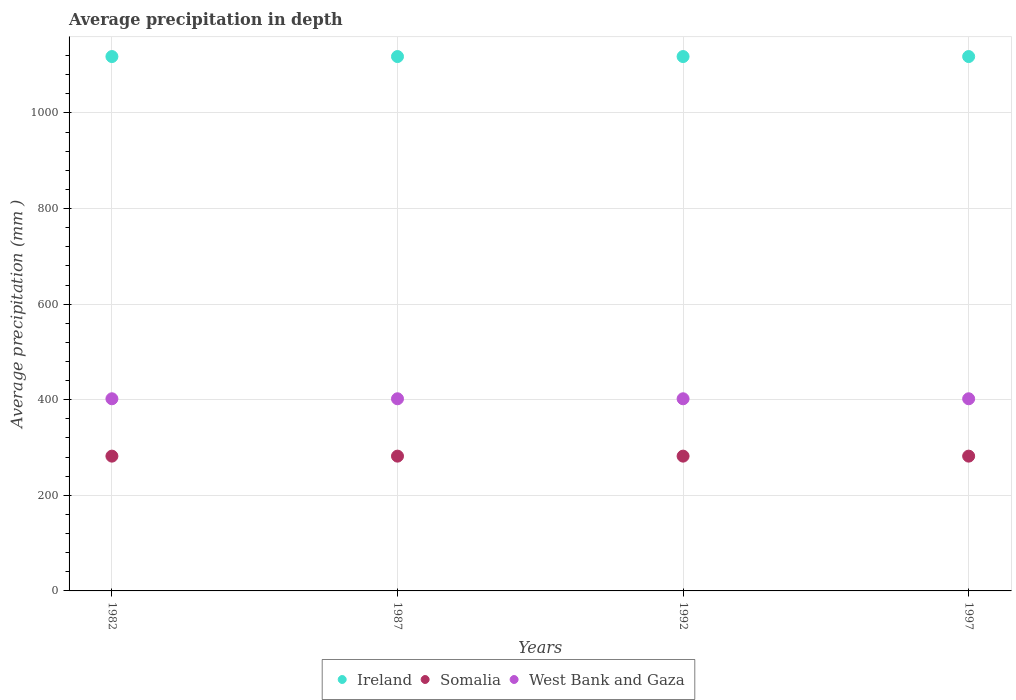What is the average precipitation in Somalia in 1992?
Your answer should be compact. 282. Across all years, what is the maximum average precipitation in West Bank and Gaza?
Your answer should be very brief. 402. Across all years, what is the minimum average precipitation in West Bank and Gaza?
Keep it short and to the point. 402. In which year was the average precipitation in Somalia minimum?
Offer a very short reply. 1982. What is the total average precipitation in Somalia in the graph?
Keep it short and to the point. 1128. What is the difference between the average precipitation in Ireland in 1987 and that in 1992?
Your response must be concise. 0. What is the difference between the average precipitation in Somalia in 1982 and the average precipitation in Ireland in 1987?
Make the answer very short. -836. What is the average average precipitation in West Bank and Gaza per year?
Provide a short and direct response. 402. In the year 1987, what is the difference between the average precipitation in West Bank and Gaza and average precipitation in Somalia?
Give a very brief answer. 120. What is the ratio of the average precipitation in Somalia in 1987 to that in 1997?
Make the answer very short. 1. Is the difference between the average precipitation in West Bank and Gaza in 1987 and 1997 greater than the difference between the average precipitation in Somalia in 1987 and 1997?
Keep it short and to the point. No. What is the difference between the highest and the second highest average precipitation in Somalia?
Offer a very short reply. 0. What is the difference between the highest and the lowest average precipitation in Somalia?
Offer a very short reply. 0. Is the average precipitation in Ireland strictly greater than the average precipitation in Somalia over the years?
Make the answer very short. Yes. Is the average precipitation in West Bank and Gaza strictly less than the average precipitation in Somalia over the years?
Provide a short and direct response. No. How many years are there in the graph?
Provide a short and direct response. 4. What is the difference between two consecutive major ticks on the Y-axis?
Your response must be concise. 200. Are the values on the major ticks of Y-axis written in scientific E-notation?
Ensure brevity in your answer.  No. Does the graph contain any zero values?
Your answer should be compact. No. Does the graph contain grids?
Ensure brevity in your answer.  Yes. What is the title of the graph?
Provide a succinct answer. Average precipitation in depth. Does "Lao PDR" appear as one of the legend labels in the graph?
Ensure brevity in your answer.  No. What is the label or title of the X-axis?
Offer a very short reply. Years. What is the label or title of the Y-axis?
Make the answer very short. Average precipitation (mm ). What is the Average precipitation (mm ) in Ireland in 1982?
Your answer should be compact. 1118. What is the Average precipitation (mm ) in Somalia in 1982?
Provide a short and direct response. 282. What is the Average precipitation (mm ) in West Bank and Gaza in 1982?
Ensure brevity in your answer.  402. What is the Average precipitation (mm ) of Ireland in 1987?
Keep it short and to the point. 1118. What is the Average precipitation (mm ) in Somalia in 1987?
Make the answer very short. 282. What is the Average precipitation (mm ) of West Bank and Gaza in 1987?
Your answer should be very brief. 402. What is the Average precipitation (mm ) of Ireland in 1992?
Provide a short and direct response. 1118. What is the Average precipitation (mm ) of Somalia in 1992?
Keep it short and to the point. 282. What is the Average precipitation (mm ) of West Bank and Gaza in 1992?
Your answer should be very brief. 402. What is the Average precipitation (mm ) of Ireland in 1997?
Offer a very short reply. 1118. What is the Average precipitation (mm ) in Somalia in 1997?
Offer a terse response. 282. What is the Average precipitation (mm ) of West Bank and Gaza in 1997?
Your response must be concise. 402. Across all years, what is the maximum Average precipitation (mm ) of Ireland?
Your response must be concise. 1118. Across all years, what is the maximum Average precipitation (mm ) of Somalia?
Offer a very short reply. 282. Across all years, what is the maximum Average precipitation (mm ) in West Bank and Gaza?
Keep it short and to the point. 402. Across all years, what is the minimum Average precipitation (mm ) in Ireland?
Give a very brief answer. 1118. Across all years, what is the minimum Average precipitation (mm ) of Somalia?
Provide a succinct answer. 282. Across all years, what is the minimum Average precipitation (mm ) in West Bank and Gaza?
Give a very brief answer. 402. What is the total Average precipitation (mm ) in Ireland in the graph?
Your response must be concise. 4472. What is the total Average precipitation (mm ) in Somalia in the graph?
Offer a very short reply. 1128. What is the total Average precipitation (mm ) of West Bank and Gaza in the graph?
Your answer should be very brief. 1608. What is the difference between the Average precipitation (mm ) in Ireland in 1982 and that in 1987?
Make the answer very short. 0. What is the difference between the Average precipitation (mm ) in West Bank and Gaza in 1982 and that in 1987?
Offer a terse response. 0. What is the difference between the Average precipitation (mm ) in Ireland in 1982 and that in 1992?
Provide a short and direct response. 0. What is the difference between the Average precipitation (mm ) in Somalia in 1982 and that in 1997?
Provide a succinct answer. 0. What is the difference between the Average precipitation (mm ) of West Bank and Gaza in 1982 and that in 1997?
Your answer should be compact. 0. What is the difference between the Average precipitation (mm ) in Ireland in 1987 and that in 1992?
Your answer should be very brief. 0. What is the difference between the Average precipitation (mm ) of Somalia in 1987 and that in 1992?
Your answer should be very brief. 0. What is the difference between the Average precipitation (mm ) in West Bank and Gaza in 1987 and that in 1992?
Your response must be concise. 0. What is the difference between the Average precipitation (mm ) of West Bank and Gaza in 1987 and that in 1997?
Your answer should be compact. 0. What is the difference between the Average precipitation (mm ) in Somalia in 1992 and that in 1997?
Your answer should be very brief. 0. What is the difference between the Average precipitation (mm ) of West Bank and Gaza in 1992 and that in 1997?
Keep it short and to the point. 0. What is the difference between the Average precipitation (mm ) of Ireland in 1982 and the Average precipitation (mm ) of Somalia in 1987?
Provide a succinct answer. 836. What is the difference between the Average precipitation (mm ) in Ireland in 1982 and the Average precipitation (mm ) in West Bank and Gaza in 1987?
Ensure brevity in your answer.  716. What is the difference between the Average precipitation (mm ) in Somalia in 1982 and the Average precipitation (mm ) in West Bank and Gaza in 1987?
Your response must be concise. -120. What is the difference between the Average precipitation (mm ) of Ireland in 1982 and the Average precipitation (mm ) of Somalia in 1992?
Give a very brief answer. 836. What is the difference between the Average precipitation (mm ) of Ireland in 1982 and the Average precipitation (mm ) of West Bank and Gaza in 1992?
Keep it short and to the point. 716. What is the difference between the Average precipitation (mm ) of Somalia in 1982 and the Average precipitation (mm ) of West Bank and Gaza in 1992?
Give a very brief answer. -120. What is the difference between the Average precipitation (mm ) of Ireland in 1982 and the Average precipitation (mm ) of Somalia in 1997?
Provide a short and direct response. 836. What is the difference between the Average precipitation (mm ) in Ireland in 1982 and the Average precipitation (mm ) in West Bank and Gaza in 1997?
Ensure brevity in your answer.  716. What is the difference between the Average precipitation (mm ) in Somalia in 1982 and the Average precipitation (mm ) in West Bank and Gaza in 1997?
Make the answer very short. -120. What is the difference between the Average precipitation (mm ) in Ireland in 1987 and the Average precipitation (mm ) in Somalia in 1992?
Your response must be concise. 836. What is the difference between the Average precipitation (mm ) of Ireland in 1987 and the Average precipitation (mm ) of West Bank and Gaza in 1992?
Ensure brevity in your answer.  716. What is the difference between the Average precipitation (mm ) of Somalia in 1987 and the Average precipitation (mm ) of West Bank and Gaza in 1992?
Offer a very short reply. -120. What is the difference between the Average precipitation (mm ) of Ireland in 1987 and the Average precipitation (mm ) of Somalia in 1997?
Provide a succinct answer. 836. What is the difference between the Average precipitation (mm ) in Ireland in 1987 and the Average precipitation (mm ) in West Bank and Gaza in 1997?
Ensure brevity in your answer.  716. What is the difference between the Average precipitation (mm ) of Somalia in 1987 and the Average precipitation (mm ) of West Bank and Gaza in 1997?
Your answer should be compact. -120. What is the difference between the Average precipitation (mm ) of Ireland in 1992 and the Average precipitation (mm ) of Somalia in 1997?
Make the answer very short. 836. What is the difference between the Average precipitation (mm ) in Ireland in 1992 and the Average precipitation (mm ) in West Bank and Gaza in 1997?
Provide a short and direct response. 716. What is the difference between the Average precipitation (mm ) of Somalia in 1992 and the Average precipitation (mm ) of West Bank and Gaza in 1997?
Give a very brief answer. -120. What is the average Average precipitation (mm ) in Ireland per year?
Give a very brief answer. 1118. What is the average Average precipitation (mm ) of Somalia per year?
Make the answer very short. 282. What is the average Average precipitation (mm ) in West Bank and Gaza per year?
Provide a short and direct response. 402. In the year 1982, what is the difference between the Average precipitation (mm ) of Ireland and Average precipitation (mm ) of Somalia?
Provide a succinct answer. 836. In the year 1982, what is the difference between the Average precipitation (mm ) of Ireland and Average precipitation (mm ) of West Bank and Gaza?
Your response must be concise. 716. In the year 1982, what is the difference between the Average precipitation (mm ) of Somalia and Average precipitation (mm ) of West Bank and Gaza?
Make the answer very short. -120. In the year 1987, what is the difference between the Average precipitation (mm ) in Ireland and Average precipitation (mm ) in Somalia?
Offer a terse response. 836. In the year 1987, what is the difference between the Average precipitation (mm ) in Ireland and Average precipitation (mm ) in West Bank and Gaza?
Offer a terse response. 716. In the year 1987, what is the difference between the Average precipitation (mm ) in Somalia and Average precipitation (mm ) in West Bank and Gaza?
Provide a short and direct response. -120. In the year 1992, what is the difference between the Average precipitation (mm ) of Ireland and Average precipitation (mm ) of Somalia?
Provide a succinct answer. 836. In the year 1992, what is the difference between the Average precipitation (mm ) of Ireland and Average precipitation (mm ) of West Bank and Gaza?
Make the answer very short. 716. In the year 1992, what is the difference between the Average precipitation (mm ) of Somalia and Average precipitation (mm ) of West Bank and Gaza?
Your answer should be compact. -120. In the year 1997, what is the difference between the Average precipitation (mm ) of Ireland and Average precipitation (mm ) of Somalia?
Your answer should be compact. 836. In the year 1997, what is the difference between the Average precipitation (mm ) in Ireland and Average precipitation (mm ) in West Bank and Gaza?
Ensure brevity in your answer.  716. In the year 1997, what is the difference between the Average precipitation (mm ) in Somalia and Average precipitation (mm ) in West Bank and Gaza?
Make the answer very short. -120. What is the ratio of the Average precipitation (mm ) in Ireland in 1982 to that in 1987?
Offer a terse response. 1. What is the ratio of the Average precipitation (mm ) of Somalia in 1982 to that in 1987?
Offer a very short reply. 1. What is the ratio of the Average precipitation (mm ) of West Bank and Gaza in 1982 to that in 1997?
Your answer should be compact. 1. What is the ratio of the Average precipitation (mm ) in Ireland in 1987 to that in 1992?
Your answer should be compact. 1. What is the ratio of the Average precipitation (mm ) in West Bank and Gaza in 1987 to that in 1992?
Your answer should be very brief. 1. What is the ratio of the Average precipitation (mm ) in Somalia in 1987 to that in 1997?
Keep it short and to the point. 1. What is the ratio of the Average precipitation (mm ) in Ireland in 1992 to that in 1997?
Give a very brief answer. 1. What is the ratio of the Average precipitation (mm ) of Somalia in 1992 to that in 1997?
Offer a very short reply. 1. What is the difference between the highest and the second highest Average precipitation (mm ) of Somalia?
Give a very brief answer. 0. What is the difference between the highest and the second highest Average precipitation (mm ) in West Bank and Gaza?
Offer a terse response. 0. What is the difference between the highest and the lowest Average precipitation (mm ) of Ireland?
Provide a succinct answer. 0. What is the difference between the highest and the lowest Average precipitation (mm ) of Somalia?
Offer a terse response. 0. 